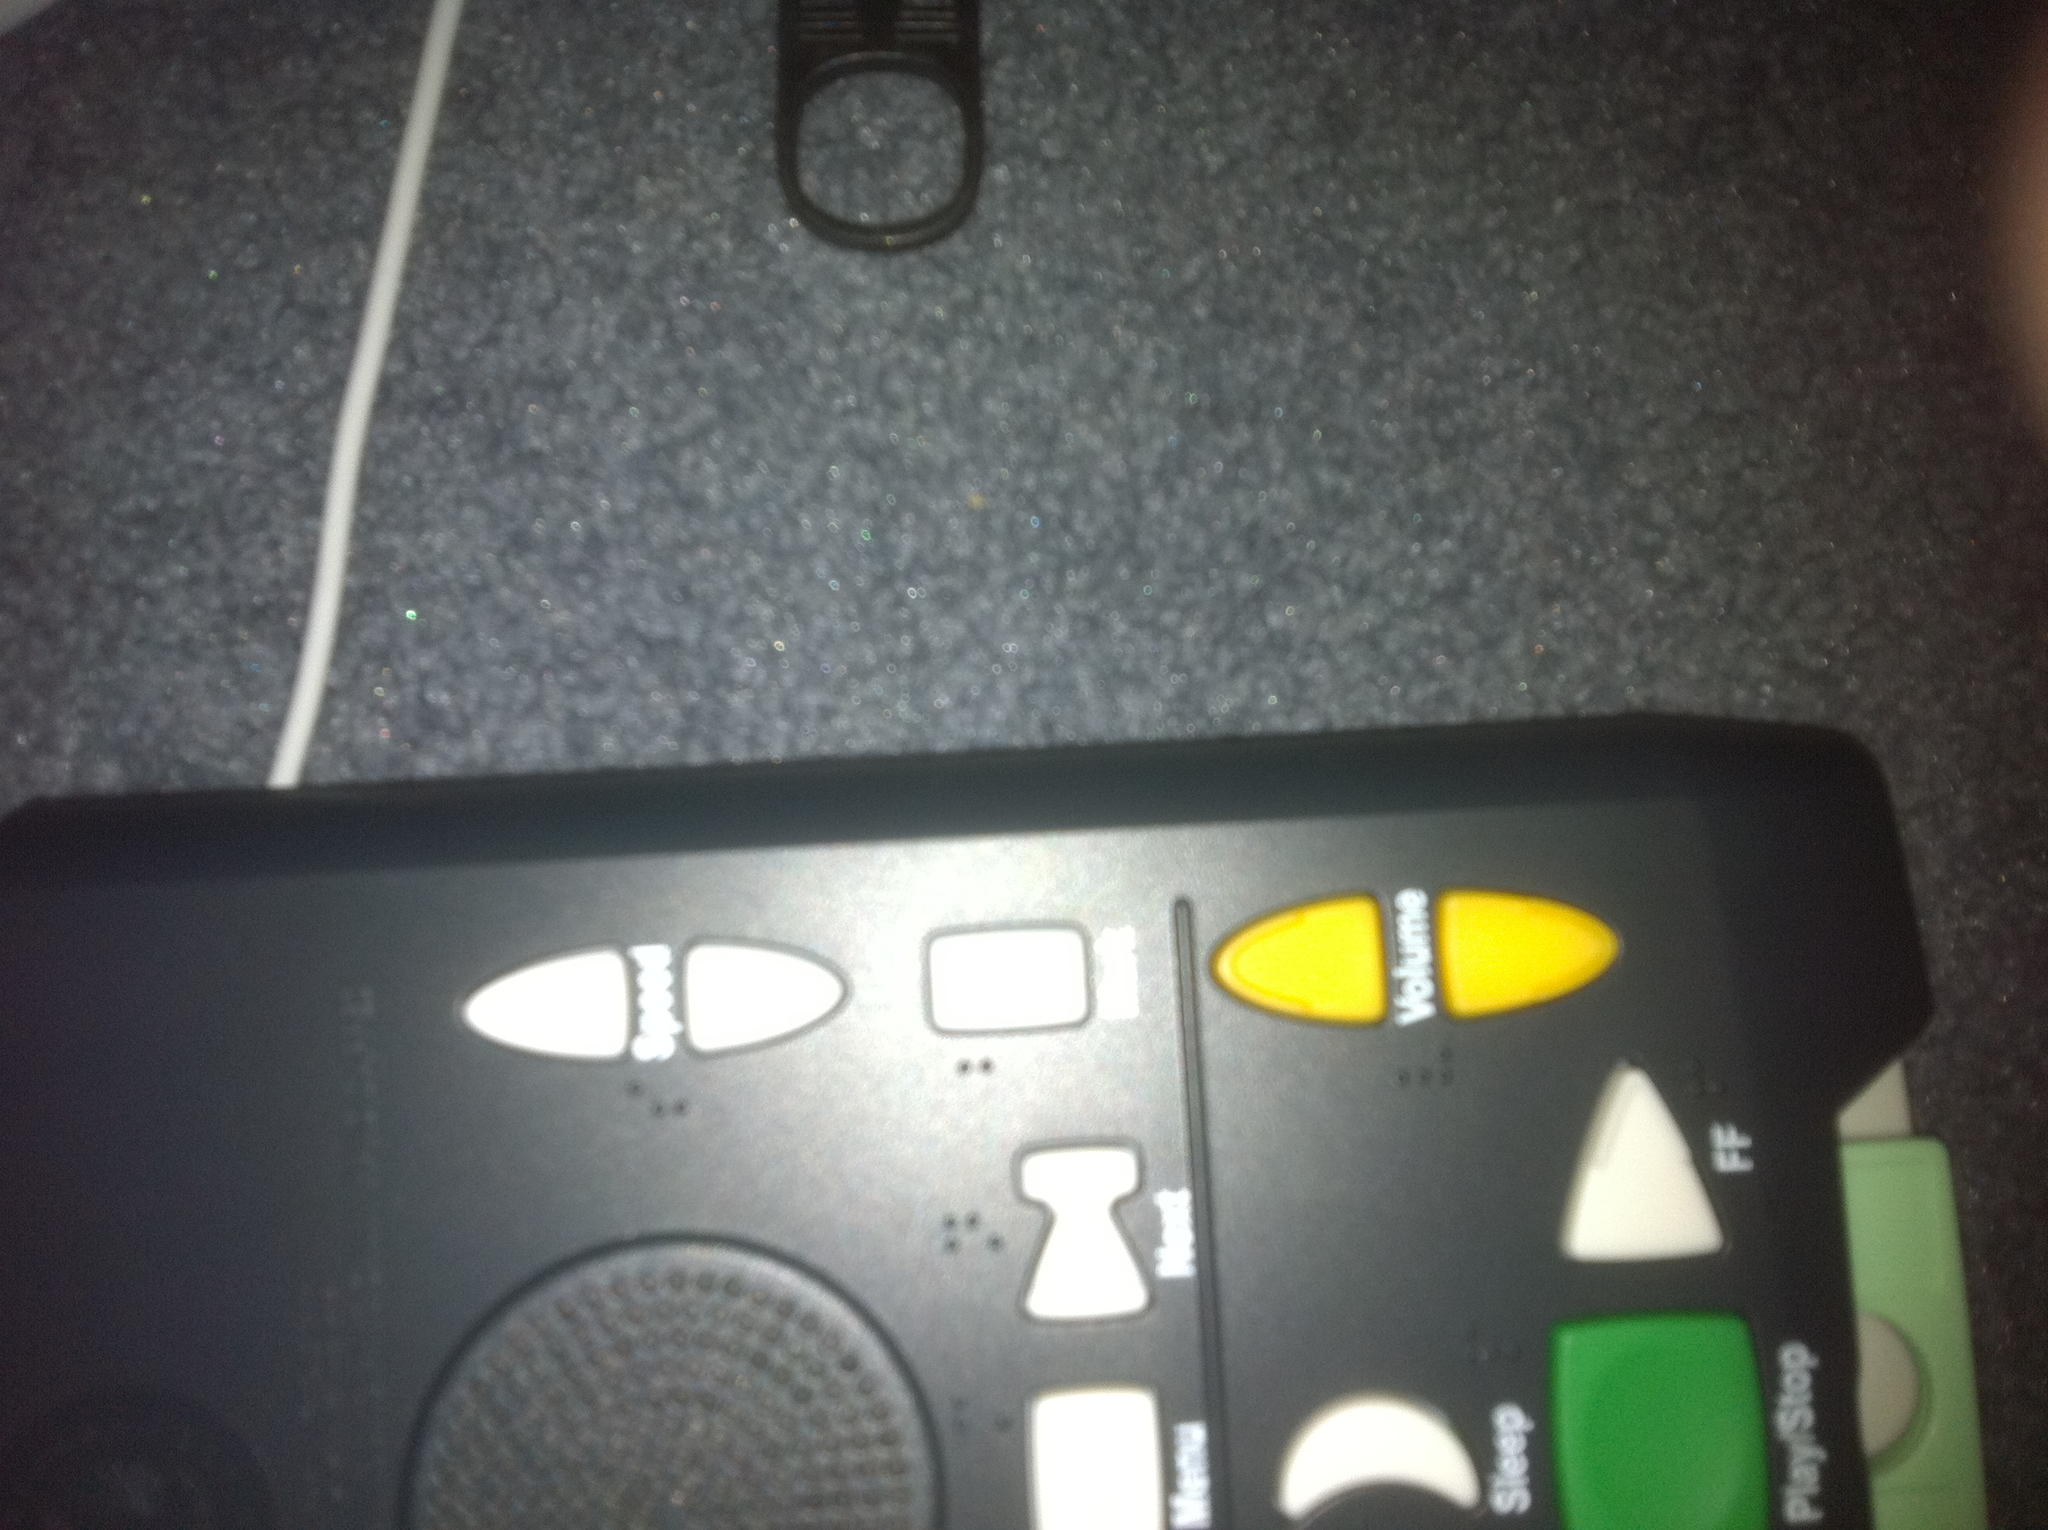What is this item and what color is it? from Vizwiz black remote control 